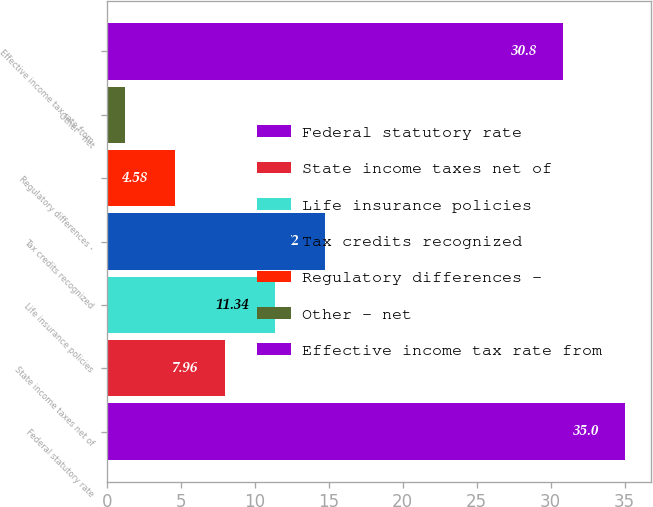Convert chart to OTSL. <chart><loc_0><loc_0><loc_500><loc_500><bar_chart><fcel>Federal statutory rate<fcel>State income taxes net of<fcel>Life insurance policies<fcel>Tax credits recognized<fcel>Regulatory differences -<fcel>Other - net<fcel>Effective income tax rate from<nl><fcel>35<fcel>7.96<fcel>11.34<fcel>14.72<fcel>4.58<fcel>1.2<fcel>30.8<nl></chart> 